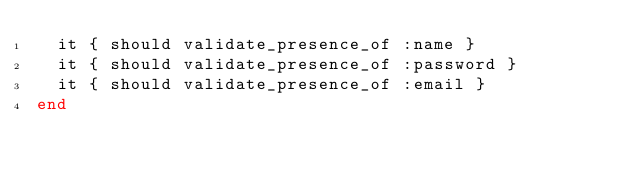Convert code to text. <code><loc_0><loc_0><loc_500><loc_500><_Ruby_>  it { should validate_presence_of :name }
  it { should validate_presence_of :password }
  it { should validate_presence_of :email }
end
</code> 